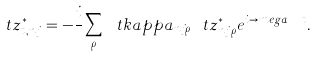<formula> <loc_0><loc_0><loc_500><loc_500>\ t z ^ { * } _ { t , n j } = - \frac { i } { } \sum _ { \rho } \ t k a p p a _ { n j \rho } \ t z ^ { * } _ { n j \rho } e ^ { i \to m e g a _ { n j \rho } t } .</formula> 